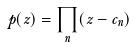<formula> <loc_0><loc_0><loc_500><loc_500>p ( z ) = \prod _ { n } ( z - c _ { n } )</formula> 